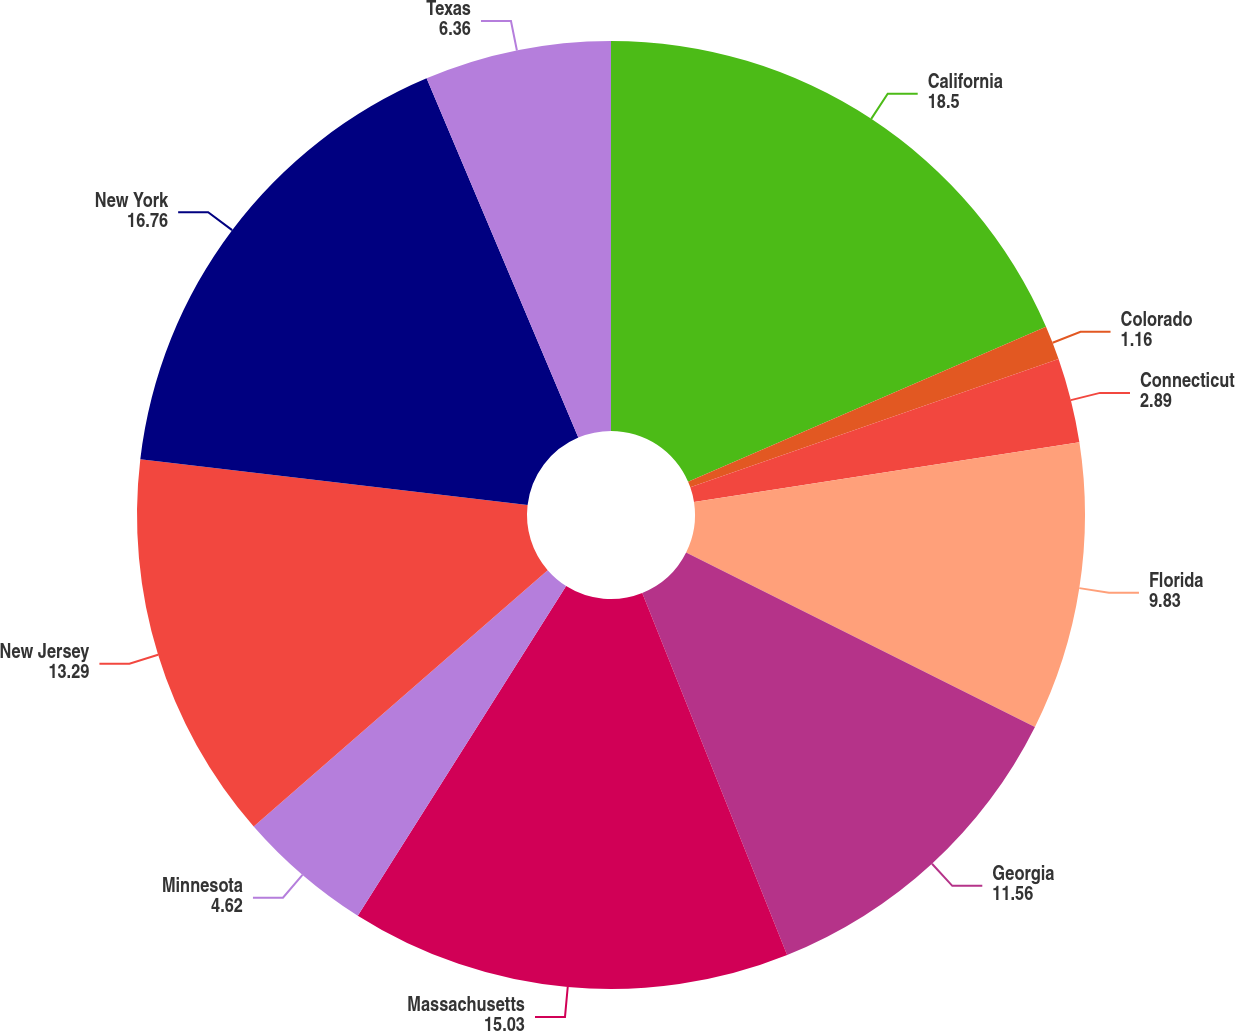<chart> <loc_0><loc_0><loc_500><loc_500><pie_chart><fcel>California<fcel>Colorado<fcel>Connecticut<fcel>Florida<fcel>Georgia<fcel>Massachusetts<fcel>Minnesota<fcel>New Jersey<fcel>New York<fcel>Texas<nl><fcel>18.5%<fcel>1.16%<fcel>2.89%<fcel>9.83%<fcel>11.56%<fcel>15.03%<fcel>4.62%<fcel>13.29%<fcel>16.76%<fcel>6.36%<nl></chart> 